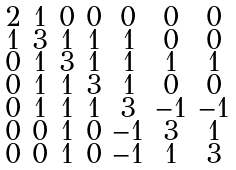<formula> <loc_0><loc_0><loc_500><loc_500>\begin{smallmatrix} 2 & 1 & 0 & 0 & 0 & 0 & 0 \\ 1 & 3 & 1 & 1 & 1 & 0 & 0 \\ 0 & 1 & 3 & 1 & 1 & 1 & 1 \\ 0 & 1 & 1 & 3 & 1 & 0 & 0 \\ 0 & 1 & 1 & 1 & 3 & - 1 & - 1 \\ 0 & 0 & 1 & 0 & - 1 & 3 & 1 \\ 0 & 0 & 1 & 0 & - 1 & 1 & 3 \end{smallmatrix}</formula> 